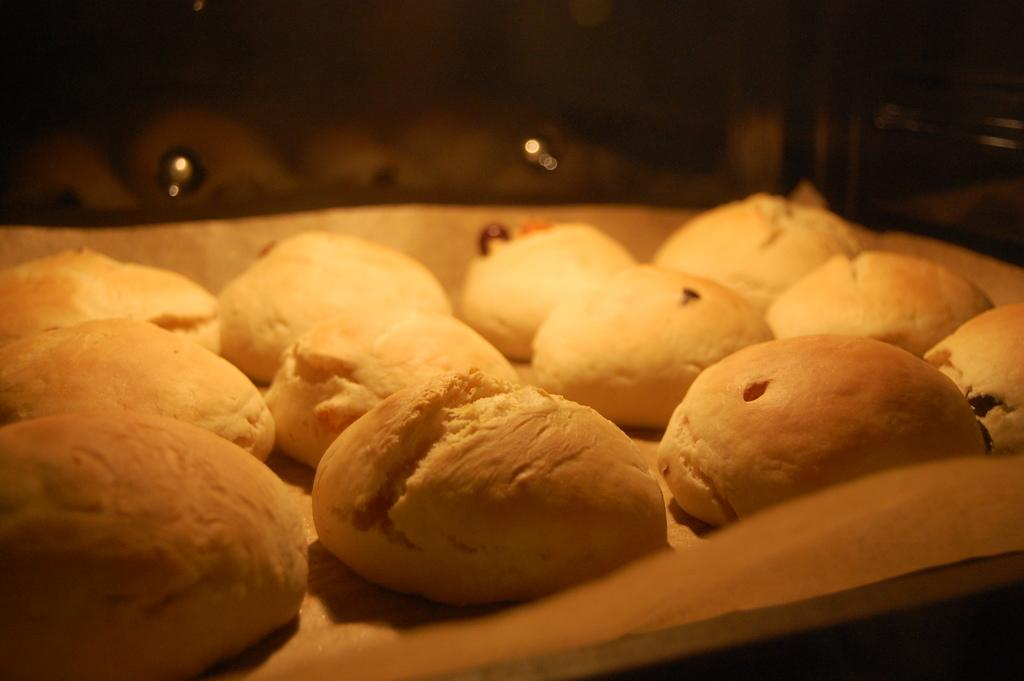What object is present in the image that can hold items? There is a tray in the image that can hold items. What is on the tray in the image? There is food on the tray in the image. Can you describe the background of the image? The background of the image is blurry. What is the governor doing in the image? There is no governor present in the image. 